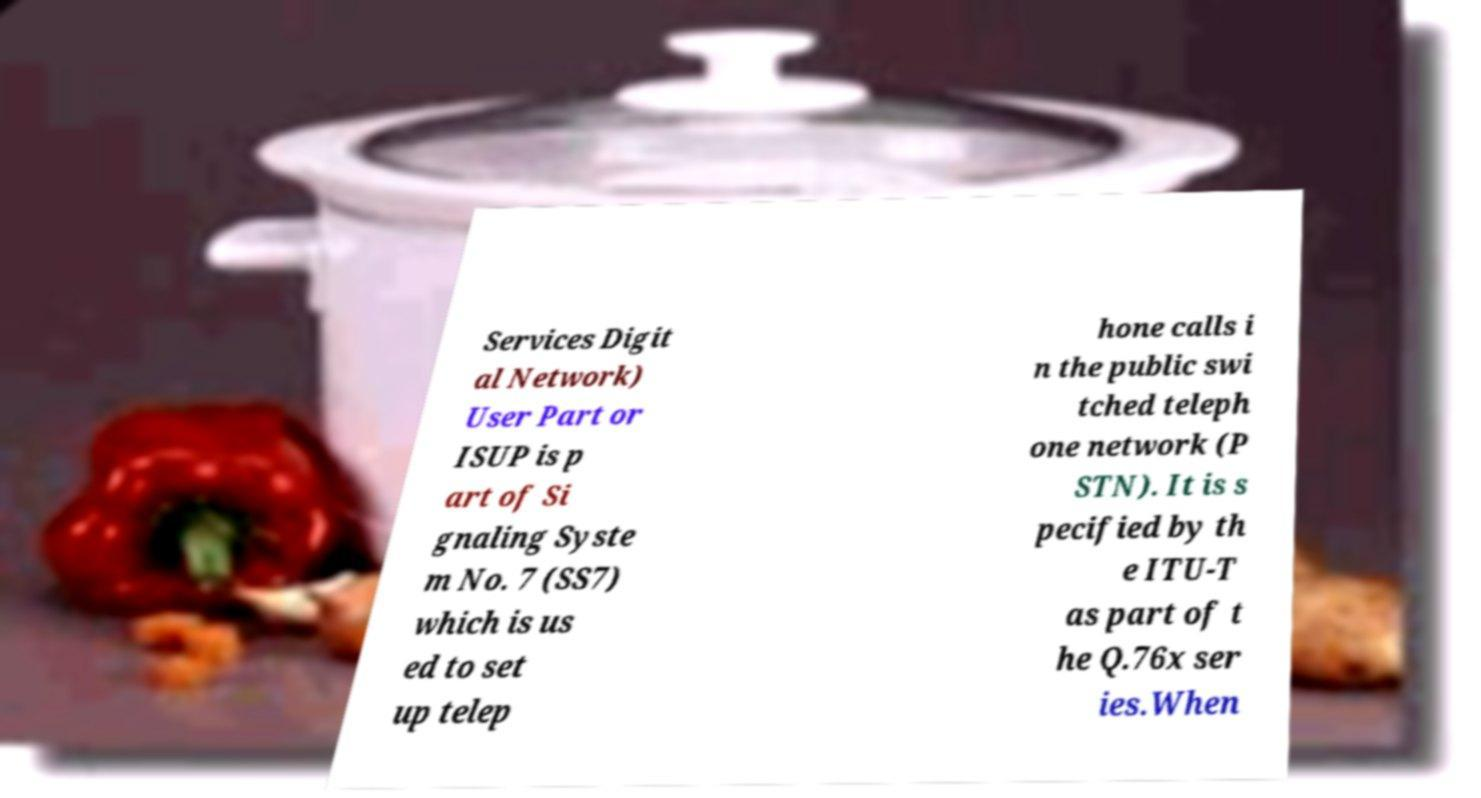Please identify and transcribe the text found in this image. Services Digit al Network) User Part or ISUP is p art of Si gnaling Syste m No. 7 (SS7) which is us ed to set up telep hone calls i n the public swi tched teleph one network (P STN). It is s pecified by th e ITU-T as part of t he Q.76x ser ies.When 